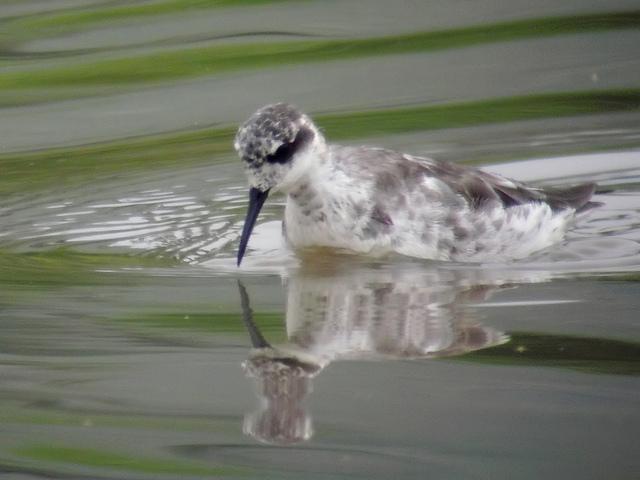What color is the bird's beak?
Give a very brief answer. Black. How many birds are there?
Keep it brief. 1. Is the bird drinking water?
Keep it brief. Yes. 